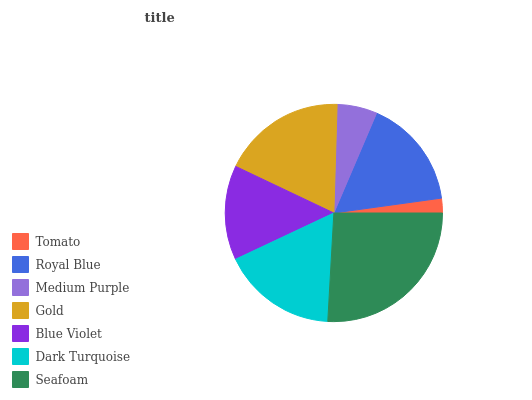Is Tomato the minimum?
Answer yes or no. Yes. Is Seafoam the maximum?
Answer yes or no. Yes. Is Royal Blue the minimum?
Answer yes or no. No. Is Royal Blue the maximum?
Answer yes or no. No. Is Royal Blue greater than Tomato?
Answer yes or no. Yes. Is Tomato less than Royal Blue?
Answer yes or no. Yes. Is Tomato greater than Royal Blue?
Answer yes or no. No. Is Royal Blue less than Tomato?
Answer yes or no. No. Is Royal Blue the high median?
Answer yes or no. Yes. Is Royal Blue the low median?
Answer yes or no. Yes. Is Dark Turquoise the high median?
Answer yes or no. No. Is Medium Purple the low median?
Answer yes or no. No. 